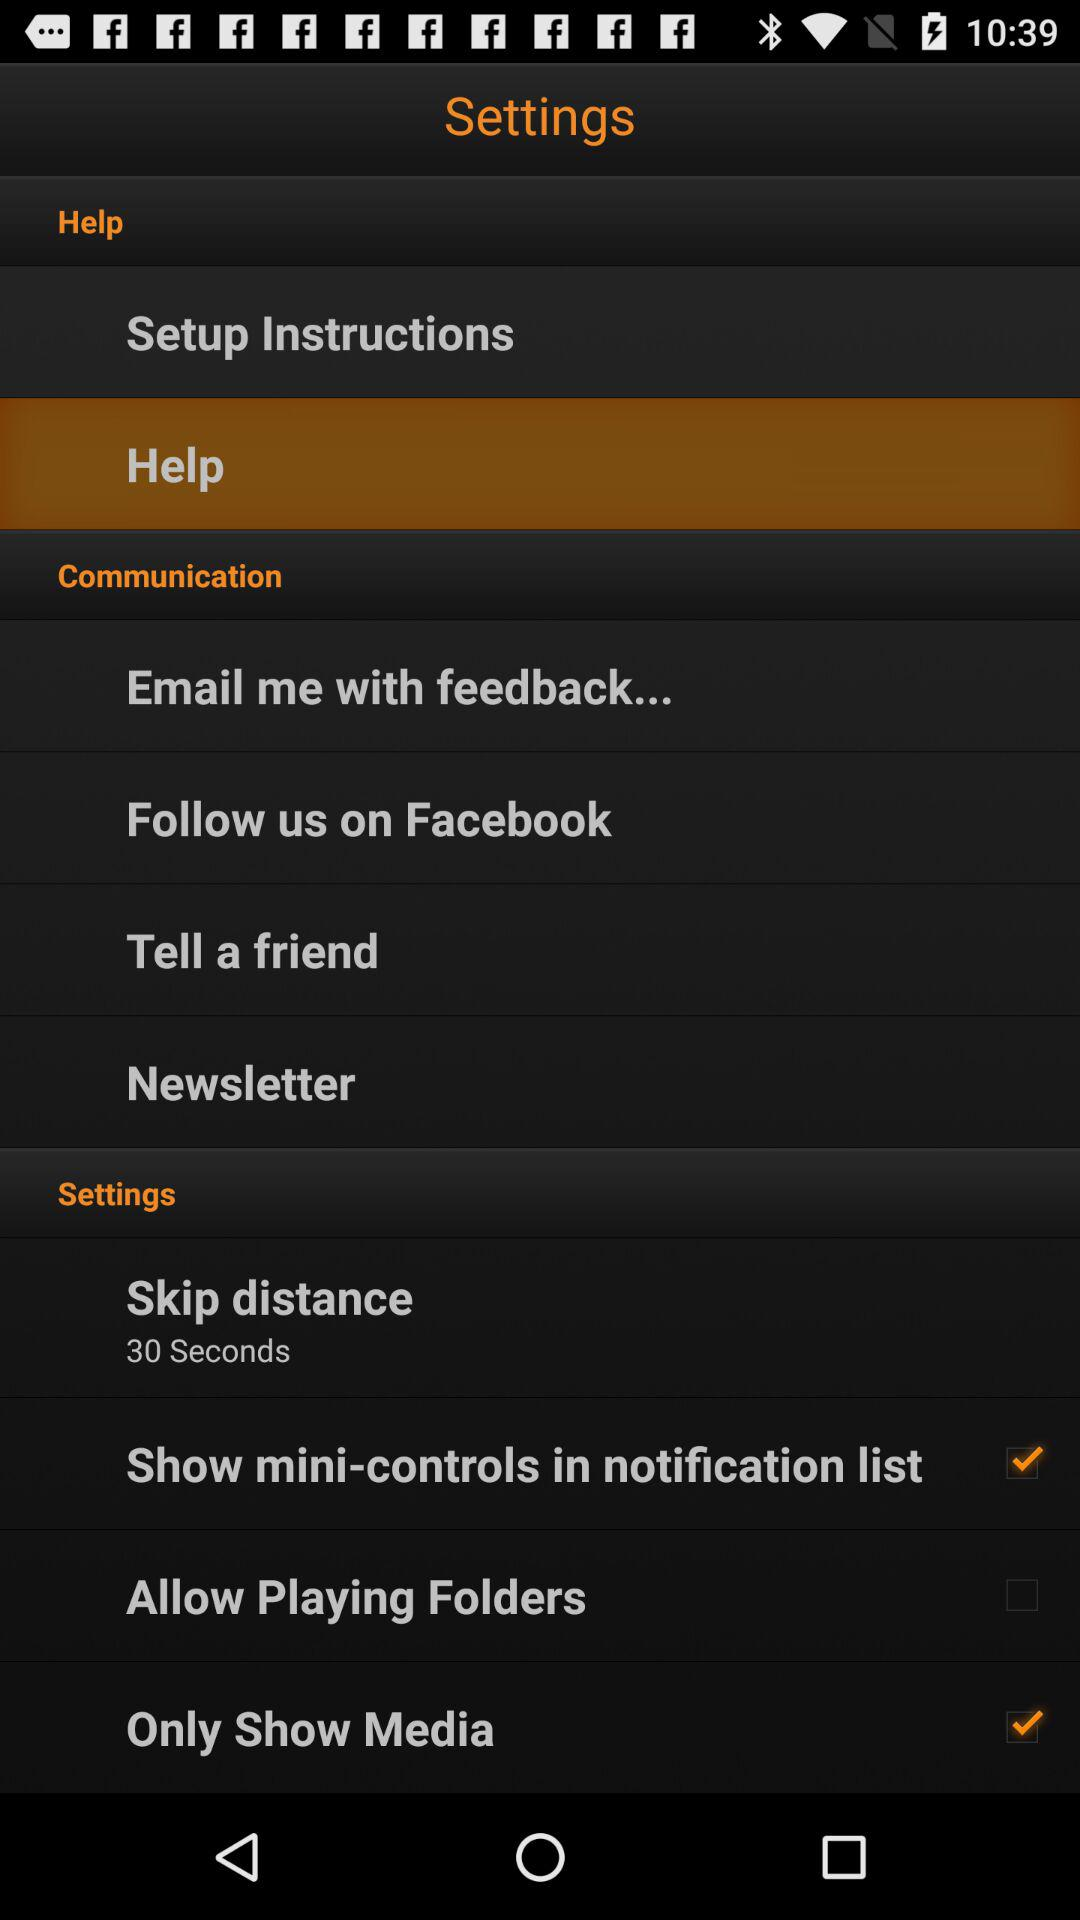What is the status of the "Only Show Media"? The status of the "Only Show Media" is "on". 